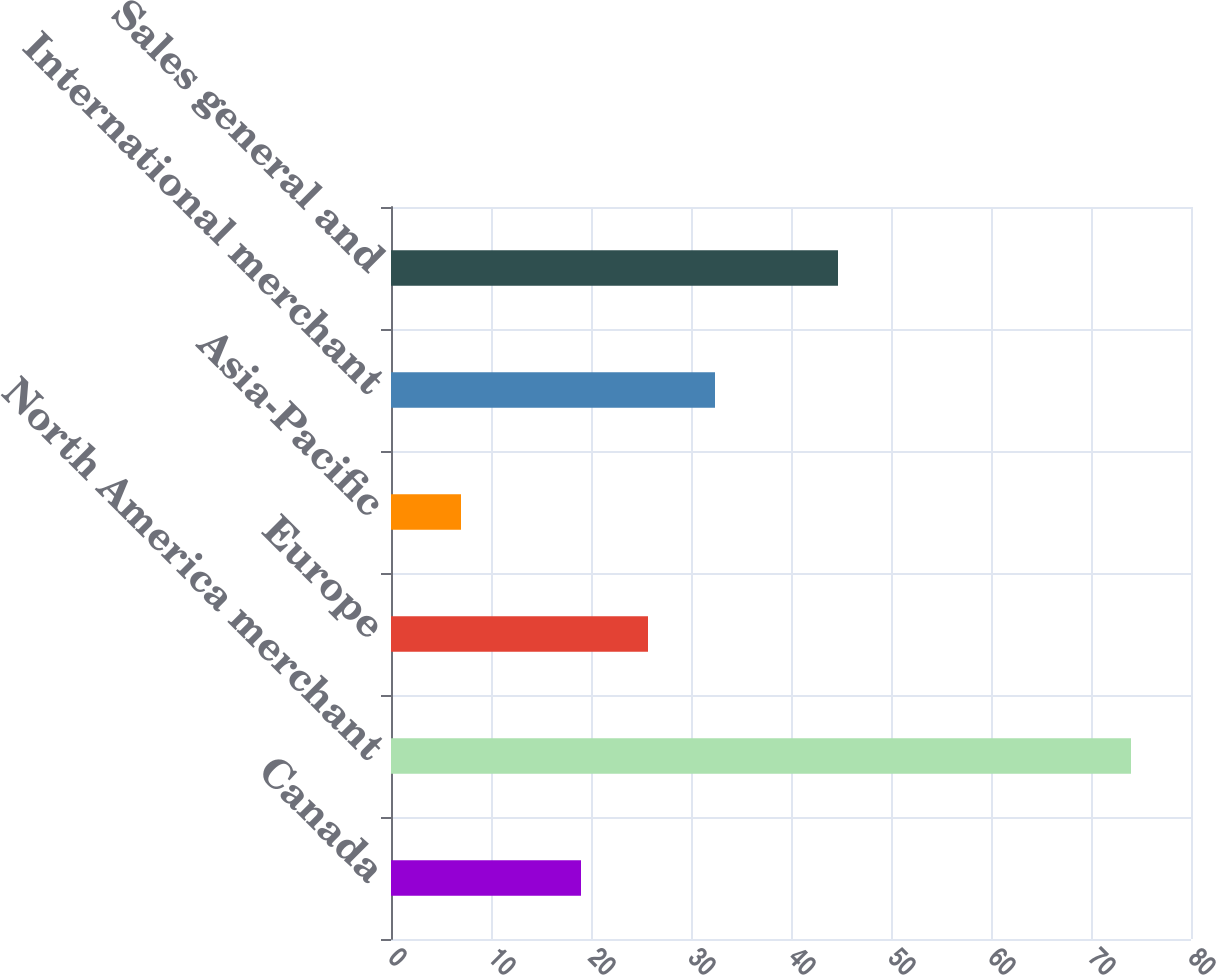Convert chart to OTSL. <chart><loc_0><loc_0><loc_500><loc_500><bar_chart><fcel>Canada<fcel>North America merchant<fcel>Europe<fcel>Asia-Pacific<fcel>International merchant<fcel>Sales general and<nl><fcel>19<fcel>74<fcel>25.7<fcel>7<fcel>32.4<fcel>44.7<nl></chart> 